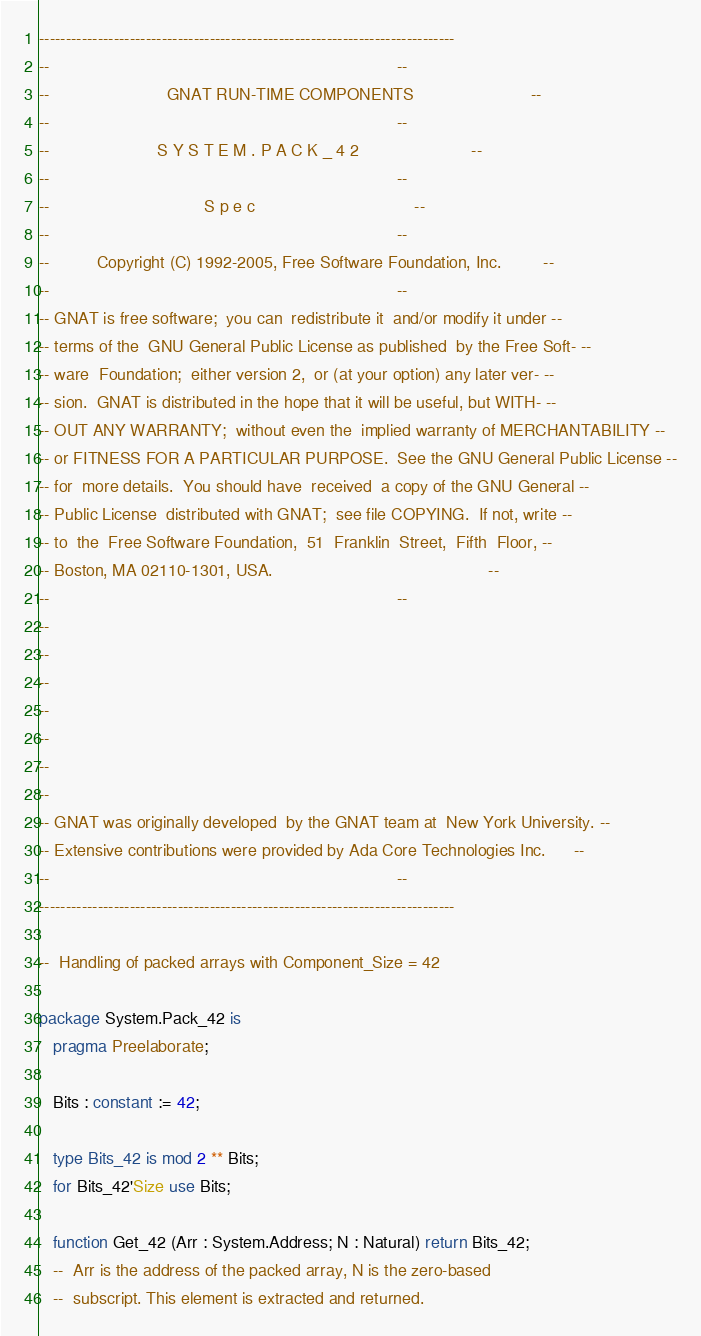Convert code to text. <code><loc_0><loc_0><loc_500><loc_500><_Ada_>------------------------------------------------------------------------------
--                                                                          --
--                         GNAT RUN-TIME COMPONENTS                         --
--                                                                          --
--                       S Y S T E M . P A C K _ 4 2                        --
--                                                                          --
--                                 S p e c                                  --
--                                                                          --
--          Copyright (C) 1992-2005, Free Software Foundation, Inc.         --
--                                                                          --
-- GNAT is free software;  you can  redistribute it  and/or modify it under --
-- terms of the  GNU General Public License as published  by the Free Soft- --
-- ware  Foundation;  either version 2,  or (at your option) any later ver- --
-- sion.  GNAT is distributed in the hope that it will be useful, but WITH- --
-- OUT ANY WARRANTY;  without even the  implied warranty of MERCHANTABILITY --
-- or FITNESS FOR A PARTICULAR PURPOSE.  See the GNU General Public License --
-- for  more details.  You should have  received  a copy of the GNU General --
-- Public License  distributed with GNAT;  see file COPYING.  If not, write --
-- to  the  Free Software Foundation,  51  Franklin  Street,  Fifth  Floor, --
-- Boston, MA 02110-1301, USA.                                              --
--                                                                          --
--
--
--
--
--
--
--
-- GNAT was originally developed  by the GNAT team at  New York University. --
-- Extensive contributions were provided by Ada Core Technologies Inc.      --
--                                                                          --
------------------------------------------------------------------------------

--  Handling of packed arrays with Component_Size = 42

package System.Pack_42 is
   pragma Preelaborate;

   Bits : constant := 42;

   type Bits_42 is mod 2 ** Bits;
   for Bits_42'Size use Bits;

   function Get_42 (Arr : System.Address; N : Natural) return Bits_42;
   --  Arr is the address of the packed array, N is the zero-based
   --  subscript. This element is extracted and returned.
</code> 